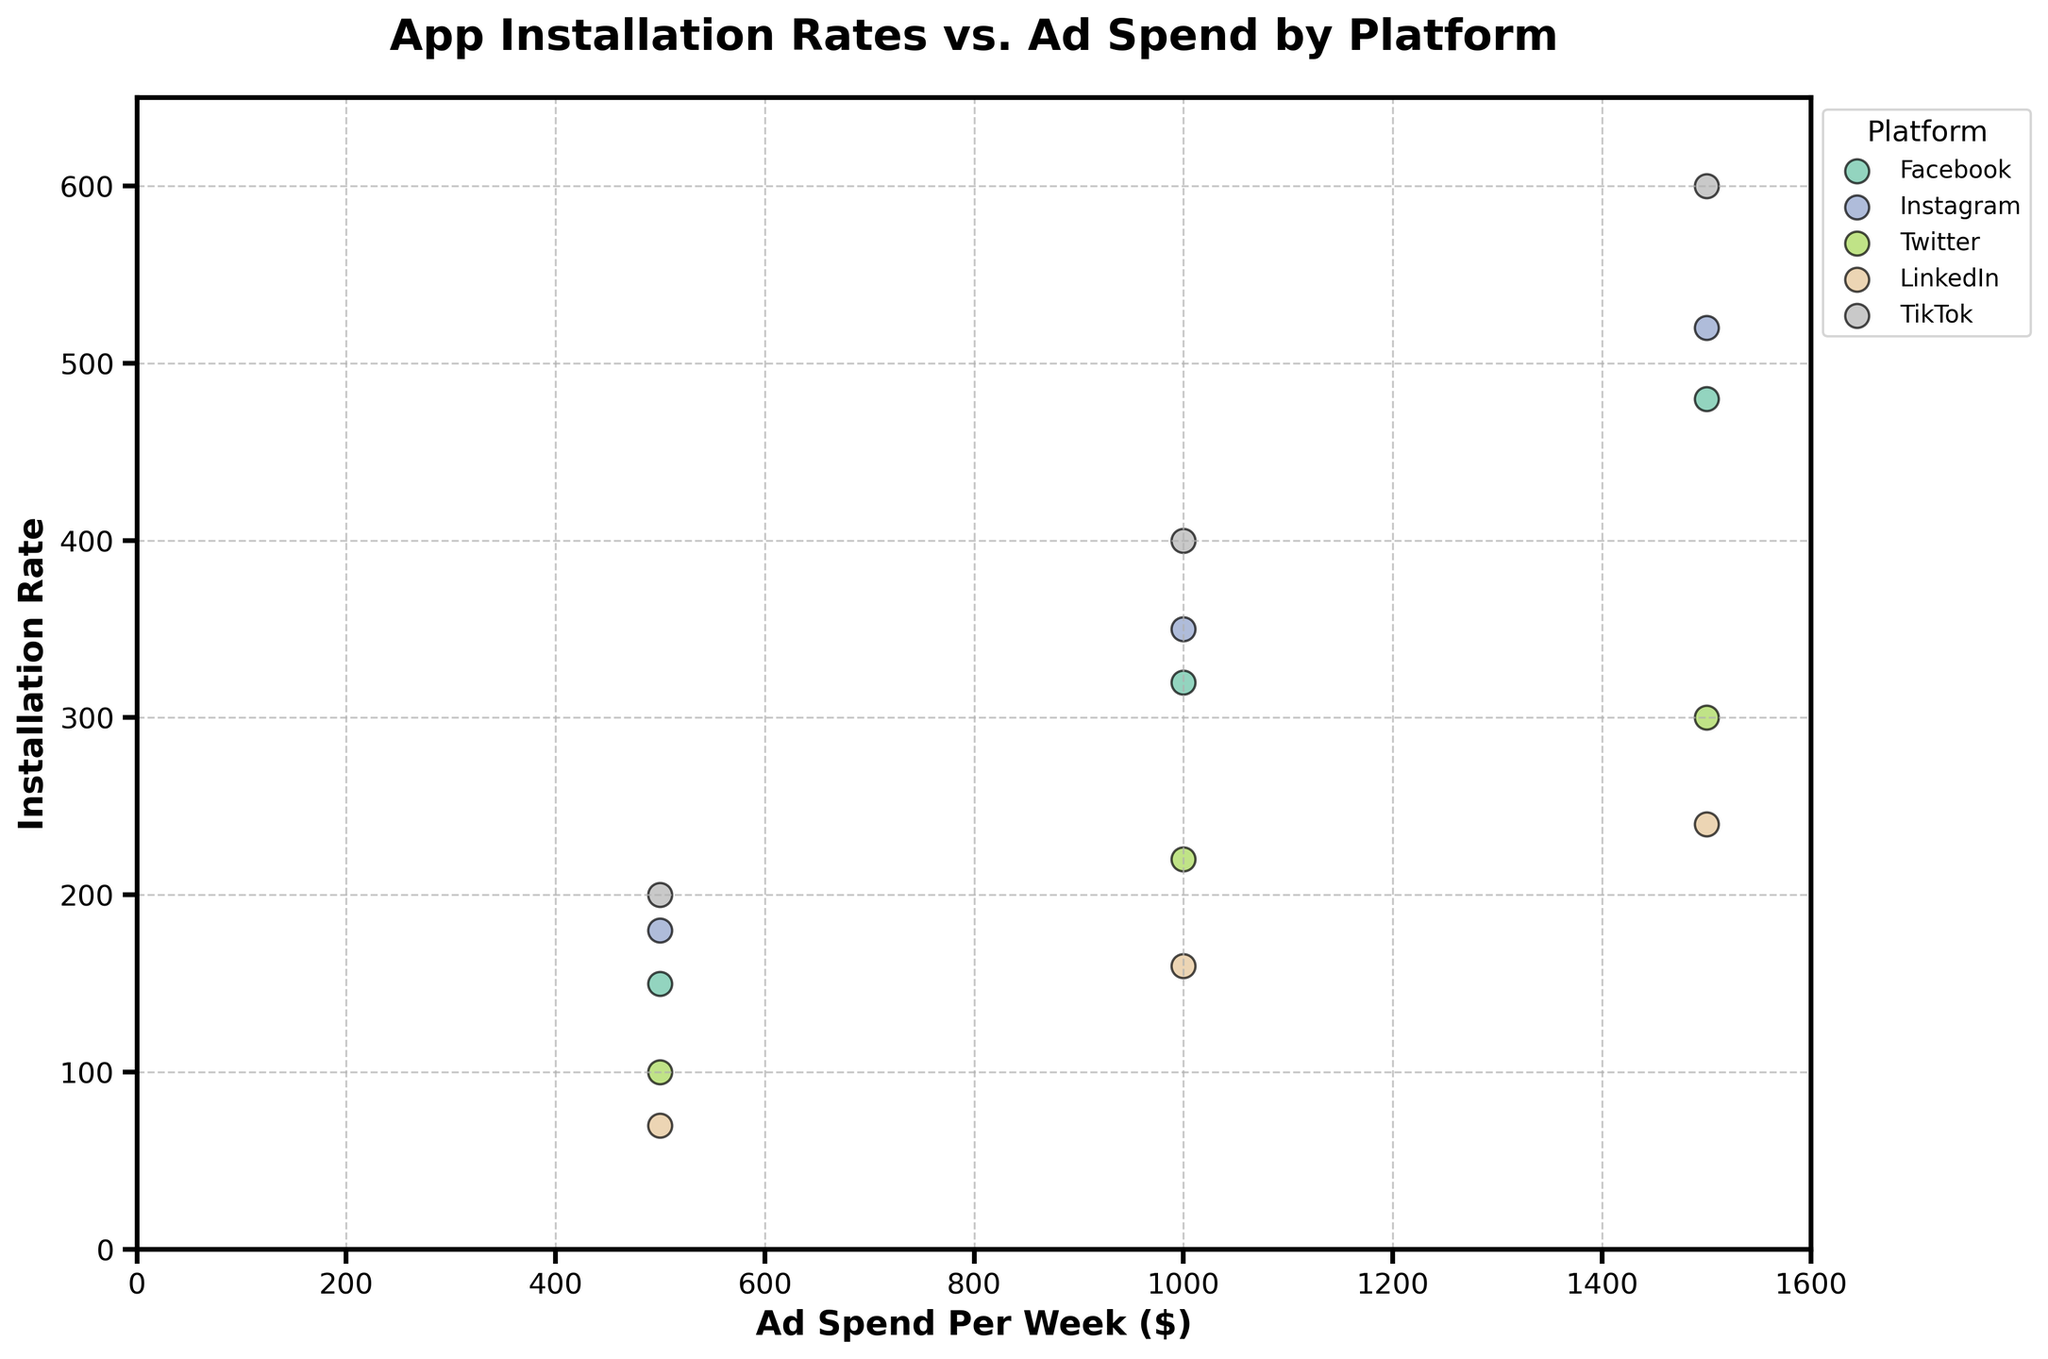What is the title of the figure? The answer is found at the top of the figure, reading the text specified as the title.
Answer: App Installation Rates vs. Ad Spend by Platform Which Social Media Platform has the highest installation rate at an ad spend of $500? Identify the data points at Ad Spend Per Week of $500 and compare their Installation Rates.
Answer: TikTok Which platform has more data points shown in the plot, Facebook or Instagram? Count the number of scatter points for both Facebook and Instagram. Each has 3 data points.
Answer: Both have 3 data points At an ad spend of $1500, which platform shows the second-highest installation rate? Identify the data points at Ad Spend Per Week of $1500, then compare their Installation Rates.
Answer: Instagram What is the difference in installation rate between TikTok and Twitter at an ad spend of $1000? Identify the installation rates for TikTok and Twitter at $1000, then subtract the Twitter rate from the TikTok rate.
Answer: 180 Which platform shows the least effectiveness (installation rate) at the maximum ad spend level ($1500)? Identify installation rates at Ad Spend Per Week of $1500 and find the platform with the lowest rate.
Answer: LinkedIn By how much does the installation rate increase on Instagram when the ad spend increases from $1000 to $1500? Identify the installation rates for Instagram at $1000 and $1500, then subtract the rate at $1000 from the rate at $1500.
Answer: 170 How does the installation rate for Facebook at an ad spend of $1000 compare to that on Twitter at the same ad spend? Identify the installation rates for both Facebook and Twitter at $1000 and compare them.
Answer: Facebook rate is higher Which platform shows a linear trend in installation rates with increasing ad spend, based on the plotted data? Observe the scatter plot patterns for consistency and linearity across different ad spends. Both Facebook and Instagram show linear trends.
Answer: Facebook or Instagram 